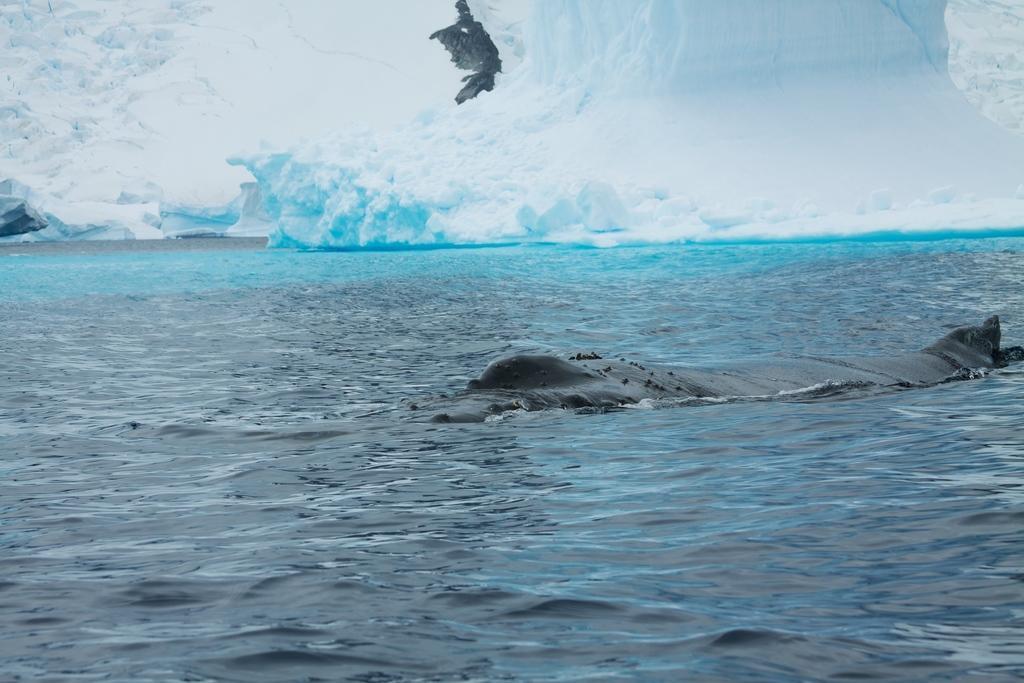Please provide a concise description of this image. There is an animal in the water. In the background there is snow. 